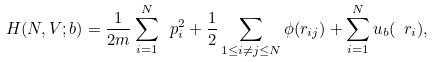<formula> <loc_0><loc_0><loc_500><loc_500>H ( N , V ; b ) = \frac { 1 } { 2 m } \sum _ { i = 1 } ^ { N } \ p _ { i } ^ { 2 } + \frac { 1 } { 2 } \sum _ { 1 \leq i \ne j \leq N } \phi ( r _ { i j } ) + \sum _ { i = 1 } ^ { N } u _ { b } ( \ r _ { i } ) ,</formula> 